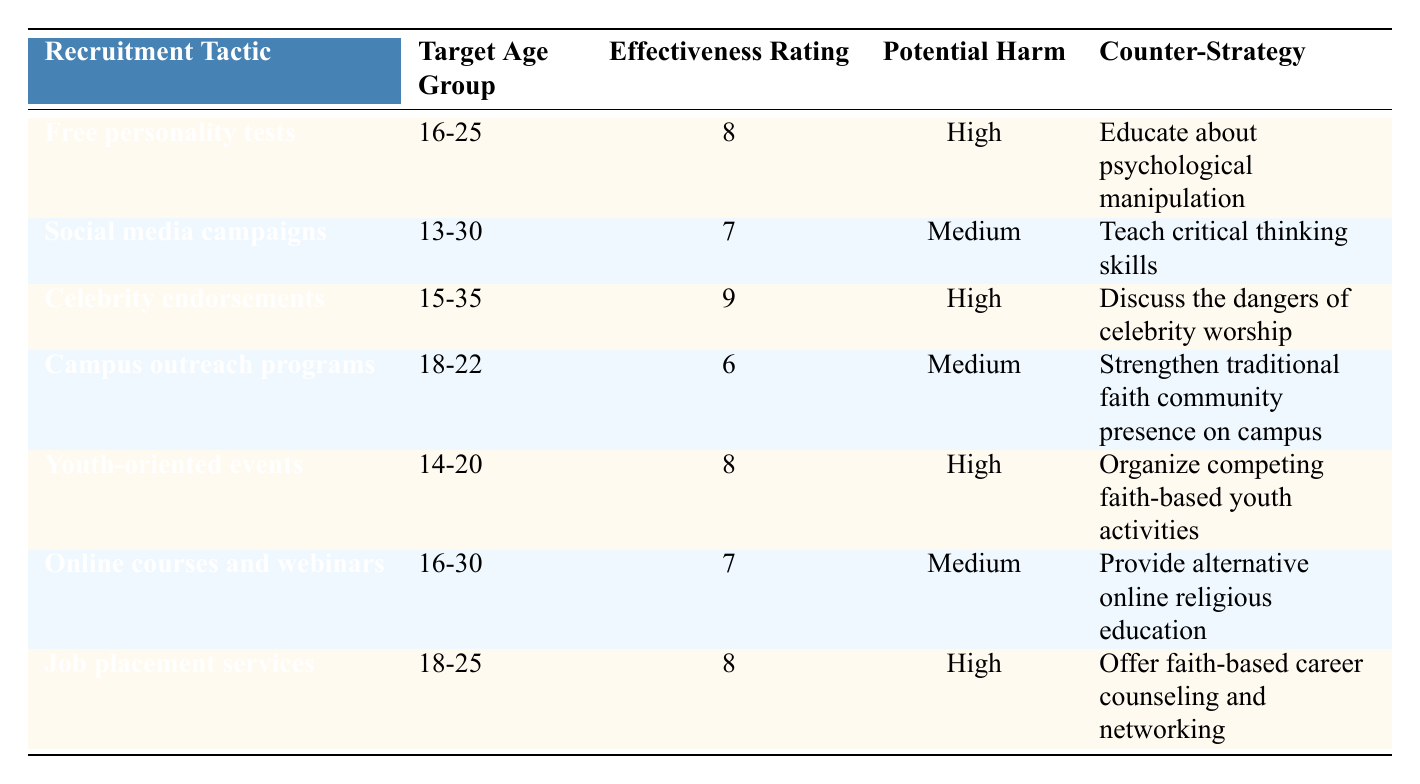What is the effectiveness rating of the recruitment tactic "Celebrity endorsements"? The table lists the effectiveness rating for "Celebrity endorsements" as 9.
Answer: 9 What age group is targeted by the tactic "Youth-oriented events"? According to the table, "Youth-oriented events" target the age group 14-20.
Answer: 14-20 Which recruitment tactic has the highest effectiveness rating? The table shows that "Celebrity endorsements" has the highest effectiveness rating of 9.
Answer: Celebrity endorsements Is the potential harm of "Online courses and webinars" considered high? The table indicates that the potential harm of "Online courses and webinars" is rated as medium, not high.
Answer: No What is the average effectiveness rating of all recruitment tactics listed in the table? To find the average, sum the effectiveness ratings: 8 + 7 + 9 + 6 + 8 + 7 + 8 = 53. There are 7 tactics, so the average is 53 / 7 = 7.57.
Answer: 7.57 How many recruitment tactics target the age group 16-25? By examining the table, there are two tactics targeting this age group: "Free personality tests" and "Job placement services."
Answer: 2 Which counter-strategy is proposed for "Social media campaigns"? The table specifies that the counter-strategy for "Social media campaigns" is to teach critical thinking skills.
Answer: Teach critical thinking skills Are there any tactics with a potential harm rating of "High"? Yes, the table shows that "Free personality tests," "Celebrity endorsements," "Youth-oriented events," and "Job placement services" have a potential harm rating of high.
Answer: Yes What is the total number of tactics that have a potential harm rating of "Medium"? The table shows that there are three tactics with a potential harm rating of medium: "Social media campaigns," "Campus outreach programs," and "Online courses and webinars."
Answer: 3 Which recruitment tactic has the same effectiveness rating as "Online courses and webinars"? The table indicates that "Social media campaigns" shares the same effectiveness rating of 7 as "Online courses and webinars."
Answer: Social media campaigns 